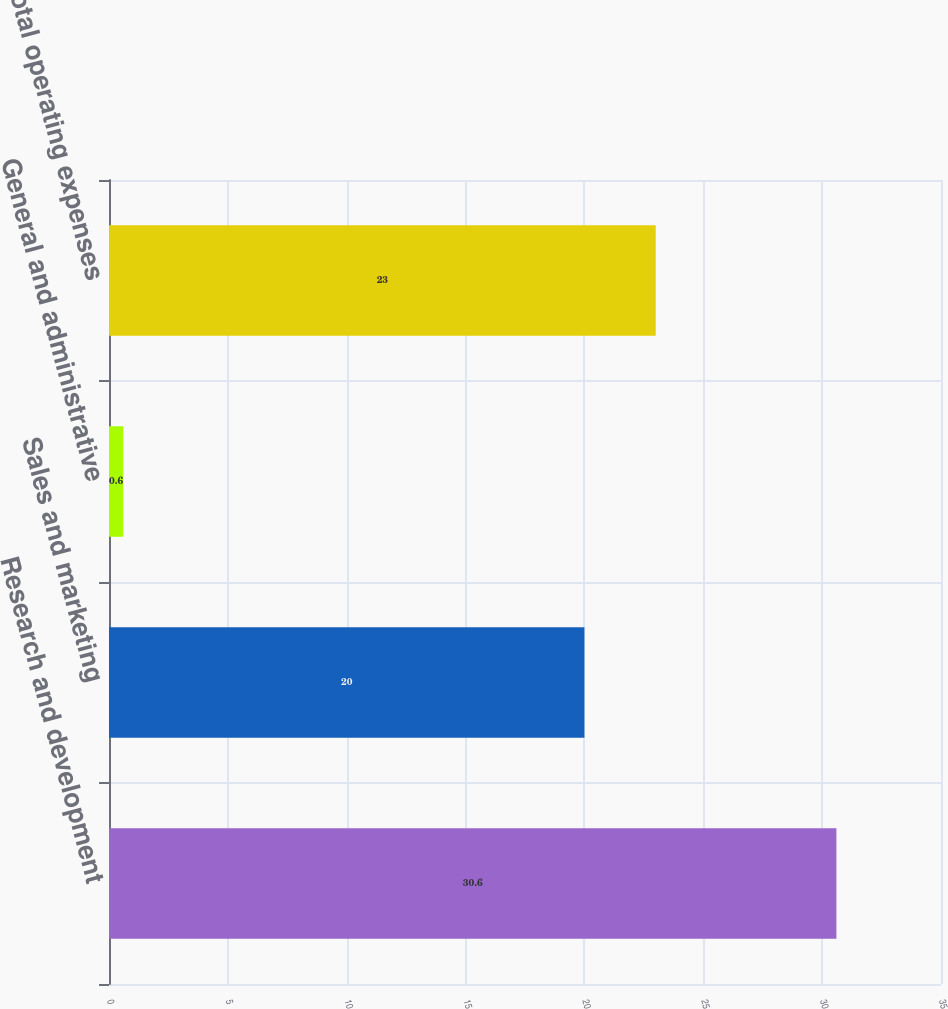Convert chart to OTSL. <chart><loc_0><loc_0><loc_500><loc_500><bar_chart><fcel>Research and development<fcel>Sales and marketing<fcel>General and administrative<fcel>Total operating expenses<nl><fcel>30.6<fcel>20<fcel>0.6<fcel>23<nl></chart> 